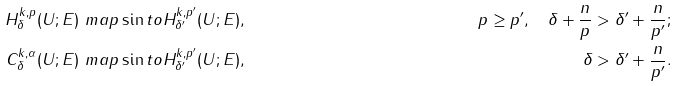<formula> <loc_0><loc_0><loc_500><loc_500>H ^ { k , p } _ { \delta } ( U ; E ) & \ m a p \sin t o H ^ { k , p ^ { \prime } } _ { \delta ^ { \prime } } ( U ; E ) , & p \geq p ^ { \prime } , \quad \delta + \frac { n } { p } & > \delta ^ { \prime } + \frac { n } { p ^ { \prime } } ; \\ C ^ { k , \alpha } _ { \delta } ( U ; E ) & \ m a p \sin t o H ^ { k , p ^ { \prime } } _ { \delta ^ { \prime } } ( U ; E ) , & \delta & > \delta ^ { \prime } + \frac { n } { p ^ { \prime } } .</formula> 